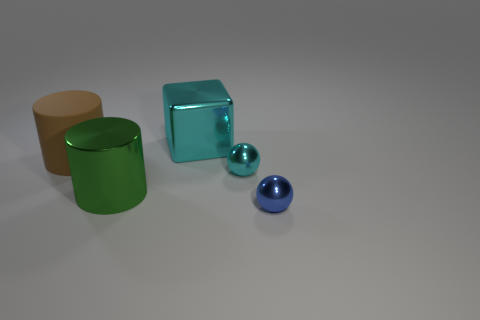Is there anything else that is made of the same material as the large brown cylinder?
Provide a succinct answer. No. Is there anything else that is the same shape as the large cyan metal object?
Offer a terse response. No. Do the brown cylinder that is to the left of the large cyan metal thing and the object in front of the green cylinder have the same size?
Offer a terse response. No. How many tiny shiny spheres have the same color as the big shiny block?
Provide a short and direct response. 1. How many large objects are either cubes or blue spheres?
Offer a very short reply. 1. Does the tiny blue ball to the right of the brown cylinder have the same material as the big brown thing?
Your answer should be compact. No. What color is the small metal ball in front of the big metallic cylinder?
Provide a short and direct response. Blue. Are there any other blue objects of the same size as the blue metallic object?
Your response must be concise. No. There is another brown cylinder that is the same size as the shiny cylinder; what is it made of?
Ensure brevity in your answer.  Rubber. Do the brown rubber object and the cylinder on the right side of the big brown object have the same size?
Provide a short and direct response. Yes. 